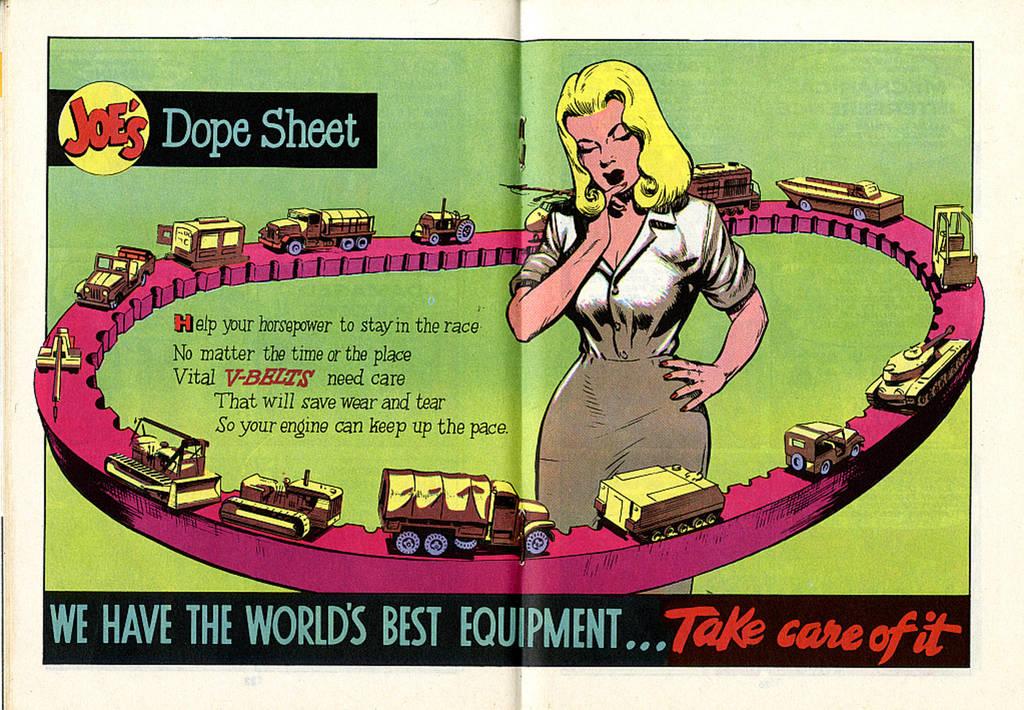What is it saying they have the world's best?
Make the answer very short. Equipment. Who's sheet is this?
Give a very brief answer. Joe's. 